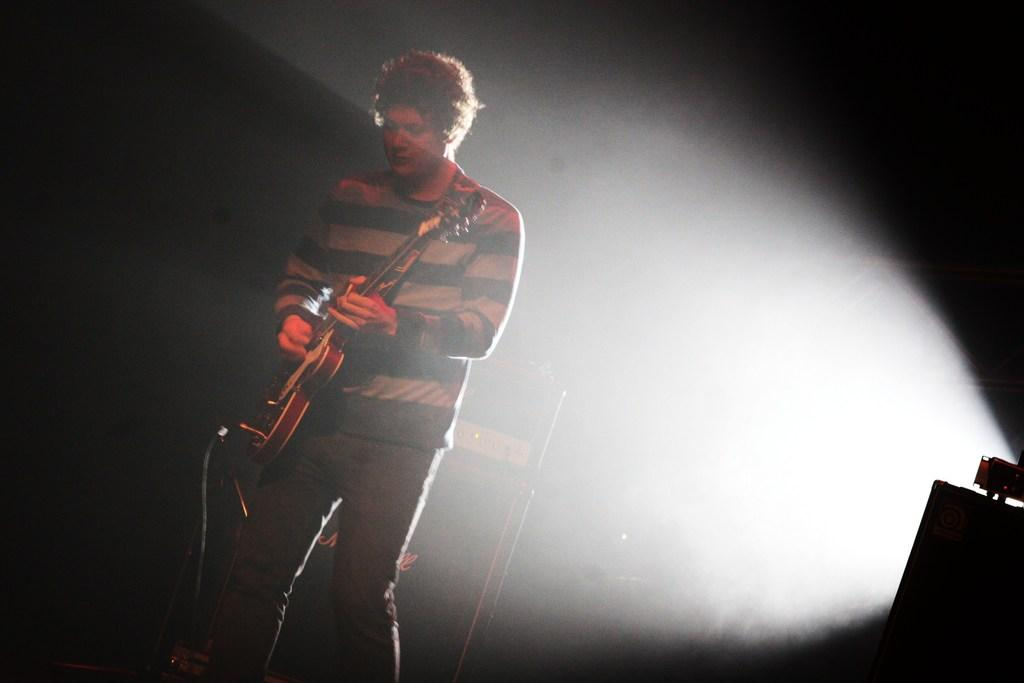Who is the person in the image? There is a man in the image. What is the man doing in the image? The man is playing a guitar. What is the man wearing in the image? The man is wearing a t-shirt. Where is the man standing in the image? The man is standing on the floor. What type of dinner is the man preparing in the image? There is no indication in the image that the man is preparing dinner, as he is playing a guitar and not engaged in any food-related activities. 